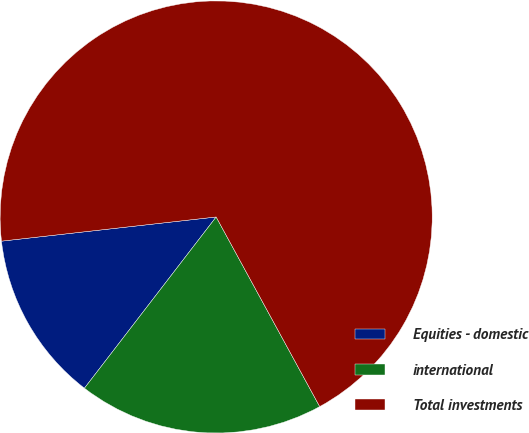<chart> <loc_0><loc_0><loc_500><loc_500><pie_chart><fcel>Equities - domestic<fcel>international<fcel>Total investments<nl><fcel>12.78%<fcel>18.39%<fcel>68.83%<nl></chart> 